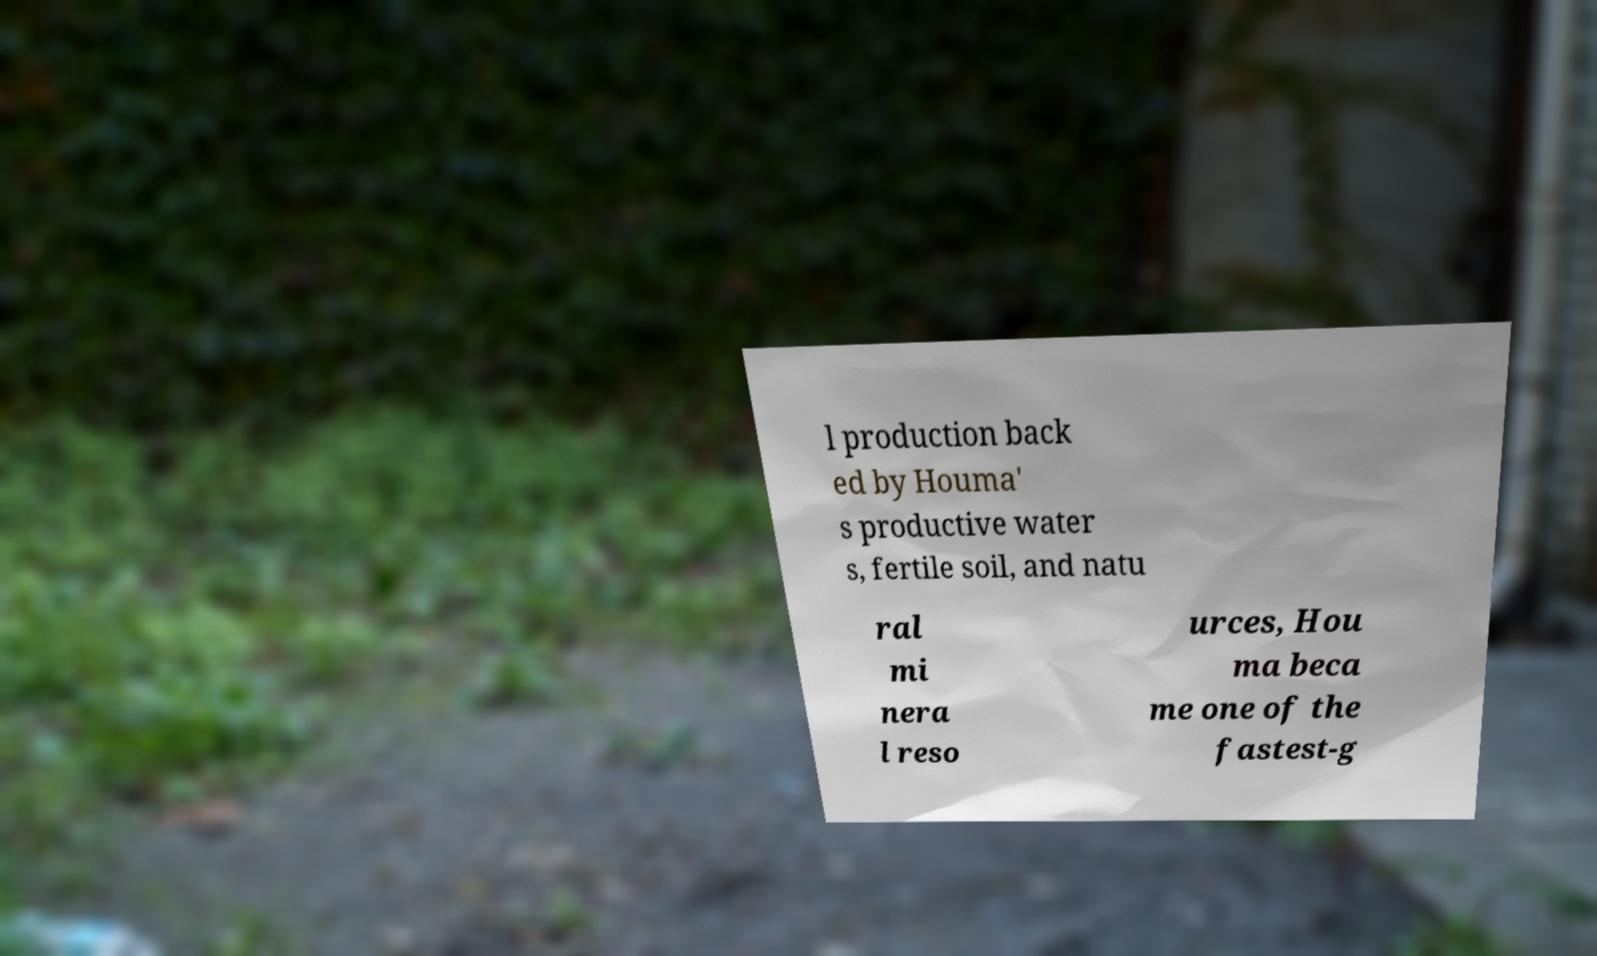Could you extract and type out the text from this image? l production back ed by Houma' s productive water s, fertile soil, and natu ral mi nera l reso urces, Hou ma beca me one of the fastest-g 